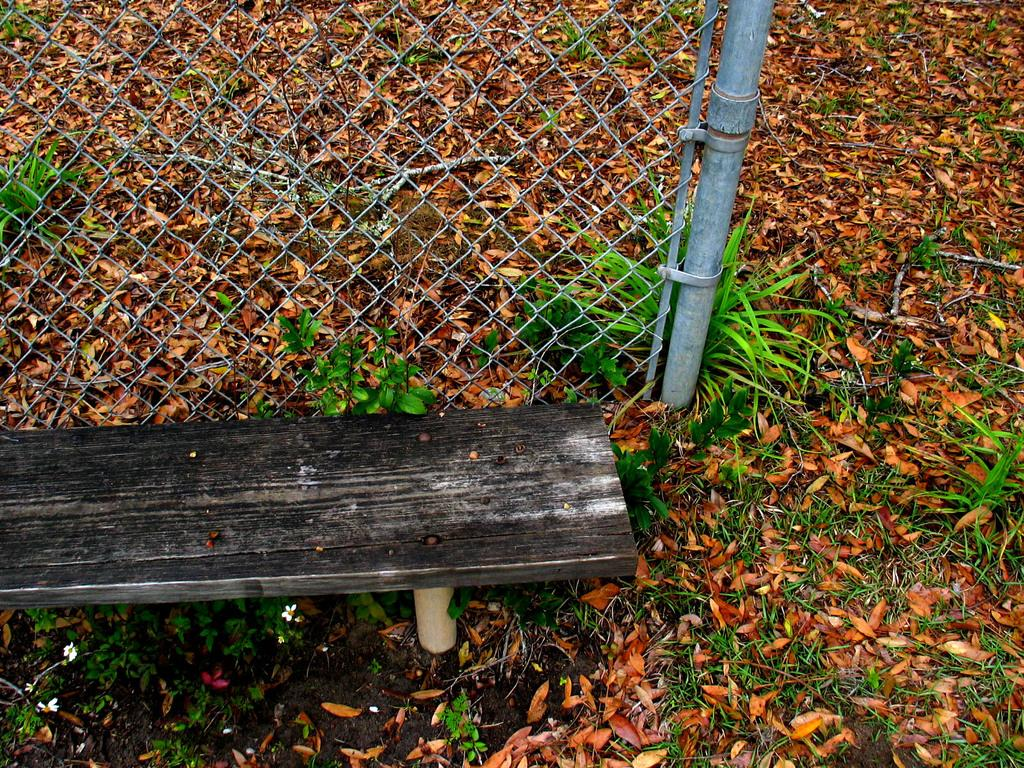What type of seating is present in the image? There is a bench in the image. What material is visible in the image? There is mesh in the image. What vertical structure is present in the image? There is a pole in the image. What type of natural debris can be seen in the image? There are dried leaves in the image. What type of vegetation is present in the image? There are plants in the image. Can you tell me how many times the person on the bench talks to the plants in the image? There is no person present in the image, so it is not possible to determine how many times they might talk to the plants. What type of watering equipment is visible in the image? There is no hose or hydrant present in the image. 